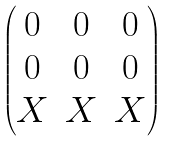<formula> <loc_0><loc_0><loc_500><loc_500>\begin{pmatrix} 0 & 0 & 0 \\ 0 & 0 & 0 \\ X & X & X \\ \end{pmatrix}</formula> 